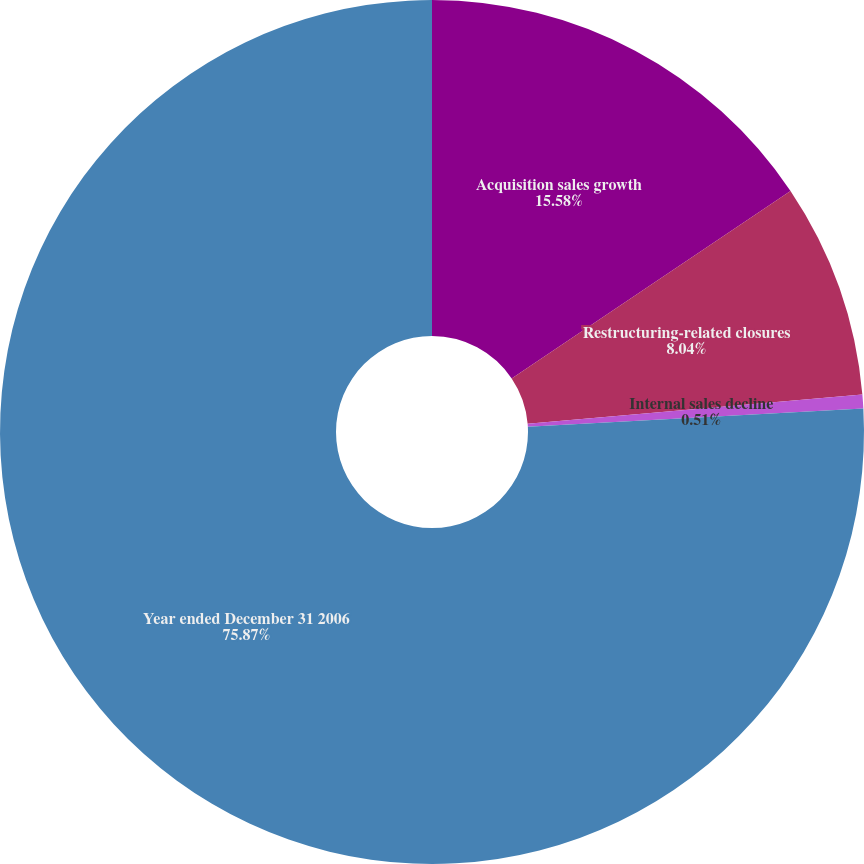Convert chart to OTSL. <chart><loc_0><loc_0><loc_500><loc_500><pie_chart><fcel>Acquisition sales growth<fcel>Restructuring-related closures<fcel>Internal sales decline<fcel>Year ended December 31 2006<nl><fcel>15.58%<fcel>8.04%<fcel>0.51%<fcel>75.87%<nl></chart> 